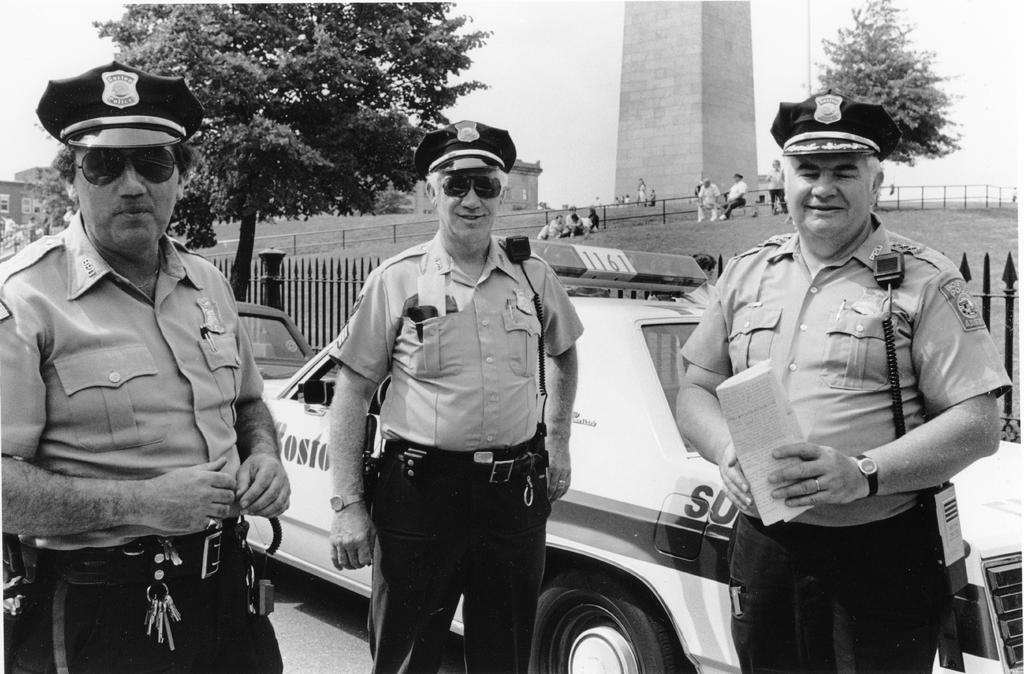Can you describe this image briefly? In this image I can see there are three men standing, they are wearing police uniforms and there are two cars behind them, there are a few people sitting on the bench at right side and there are few trees and there is a monument and the sky is clear. 